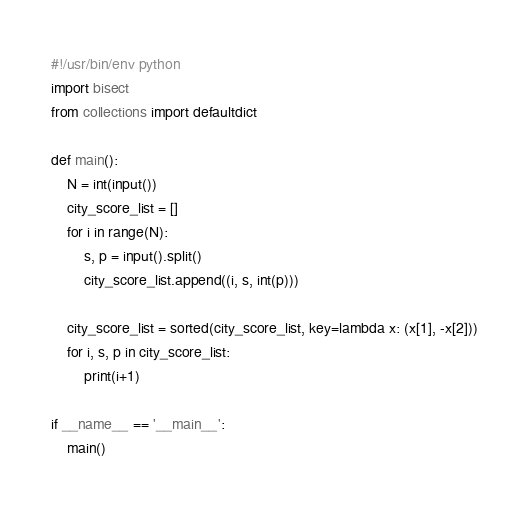<code> <loc_0><loc_0><loc_500><loc_500><_Python_>#!/usr/bin/env python
import bisect
from collections import defaultdict

def main():
    N = int(input())
    city_score_list = []
    for i in range(N):
        s, p = input().split()
        city_score_list.append((i, s, int(p)))

    city_score_list = sorted(city_score_list, key=lambda x: (x[1], -x[2]))
    for i, s, p in city_score_list:
        print(i+1)

if __name__ == '__main__':
    main()
</code> 